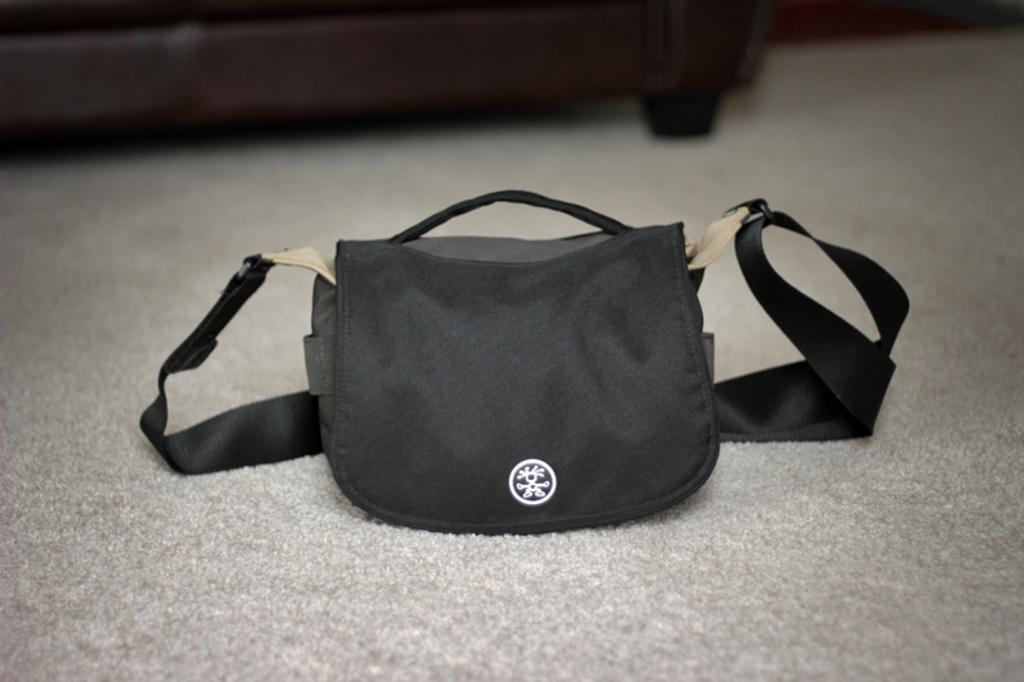What color is the bag in the image? The bag in the image is black. What feature can be seen on the bag? The bag has a black belt. What time does the clock on the bag show in the image? There is no clock present on the bag in the image. What type of soup is being served in the bowl next to the bag? There is no bowl or soup present in the image; it only features a black color bag with a black belt. 